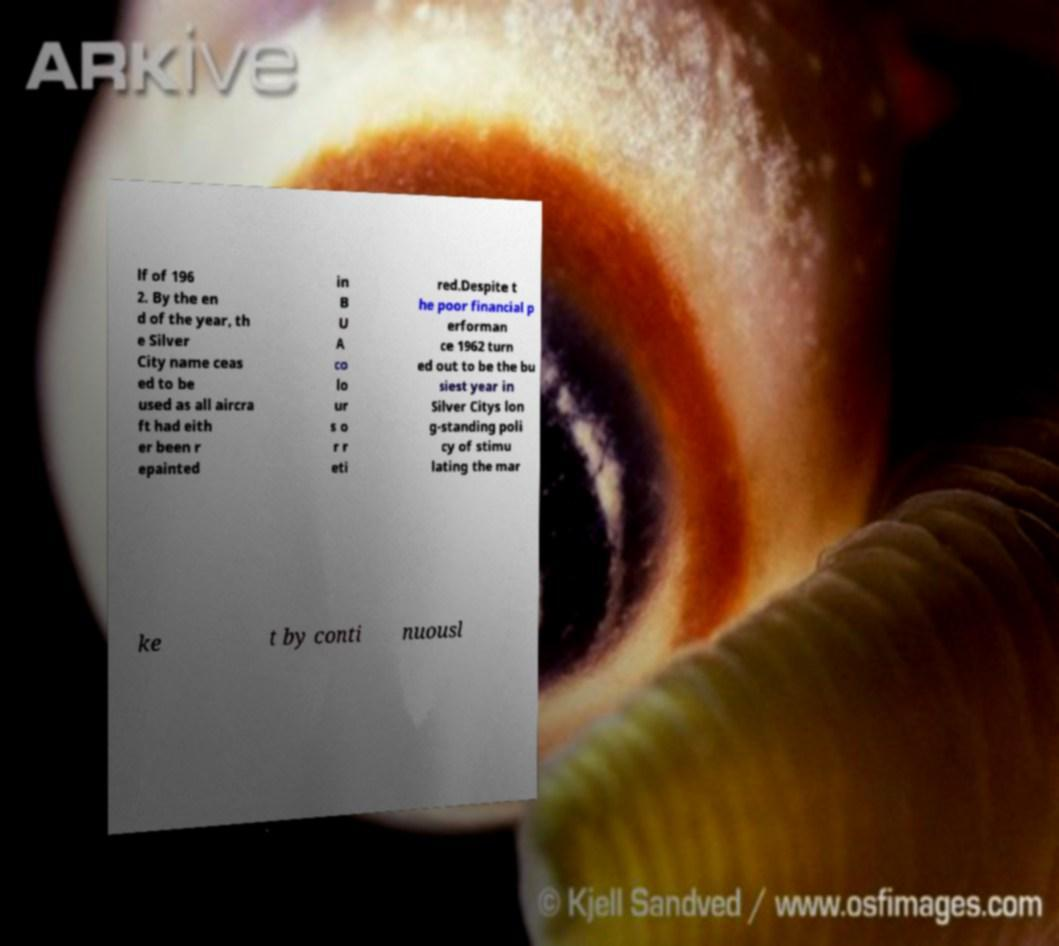Could you assist in decoding the text presented in this image and type it out clearly? lf of 196 2. By the en d of the year, th e Silver City name ceas ed to be used as all aircra ft had eith er been r epainted in B U A co lo ur s o r r eti red.Despite t he poor financial p erforman ce 1962 turn ed out to be the bu siest year in Silver Citys lon g-standing poli cy of stimu lating the mar ke t by conti nuousl 